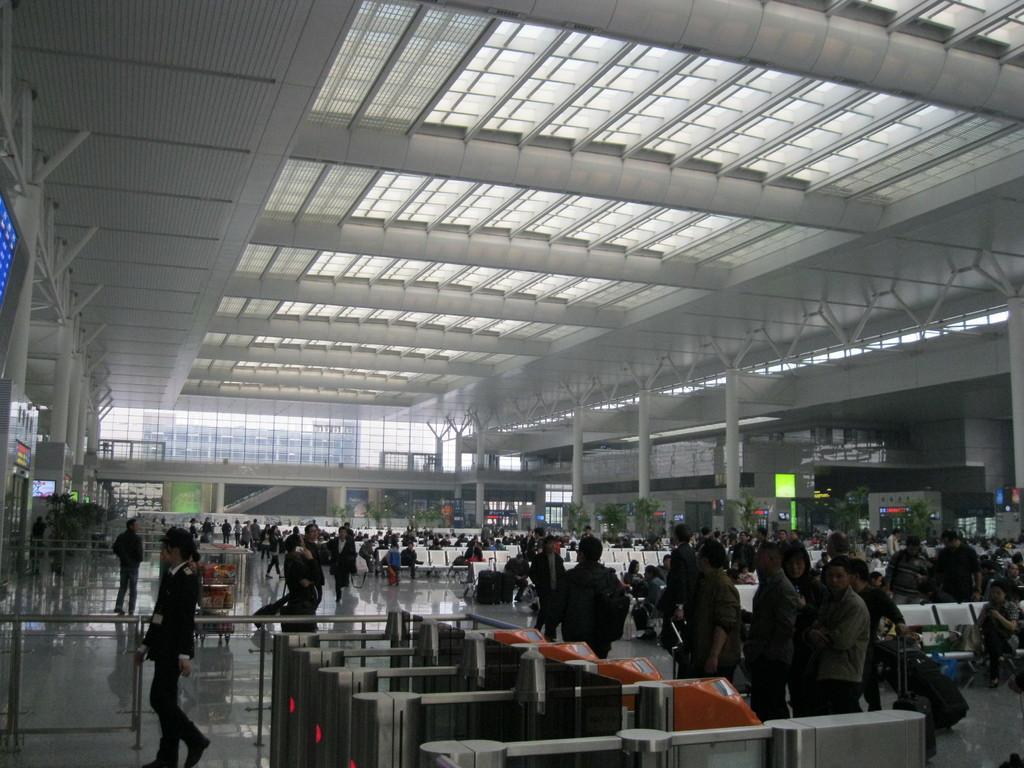Can you describe this image briefly? On the left side a person is walking, this person wore black color coat. On the right side few people are walking. 